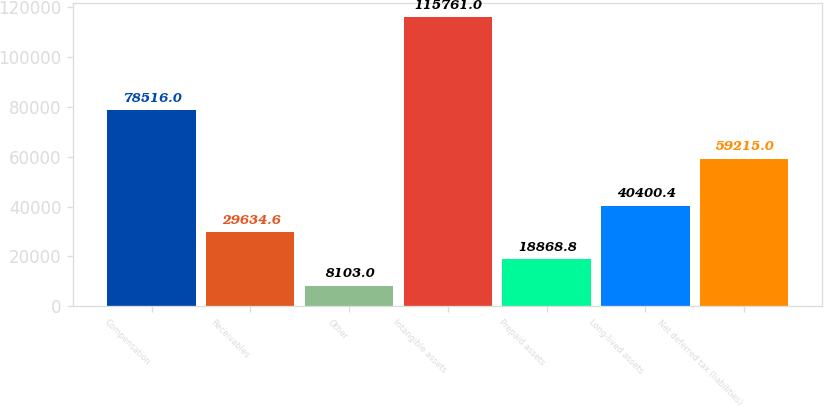<chart> <loc_0><loc_0><loc_500><loc_500><bar_chart><fcel>Compensation<fcel>Receivables<fcel>Other<fcel>Intangible assets<fcel>Prepaid assets<fcel>Long-lived assets<fcel>Net deferred tax (liabilities)<nl><fcel>78516<fcel>29634.6<fcel>8103<fcel>115761<fcel>18868.8<fcel>40400.4<fcel>59215<nl></chart> 